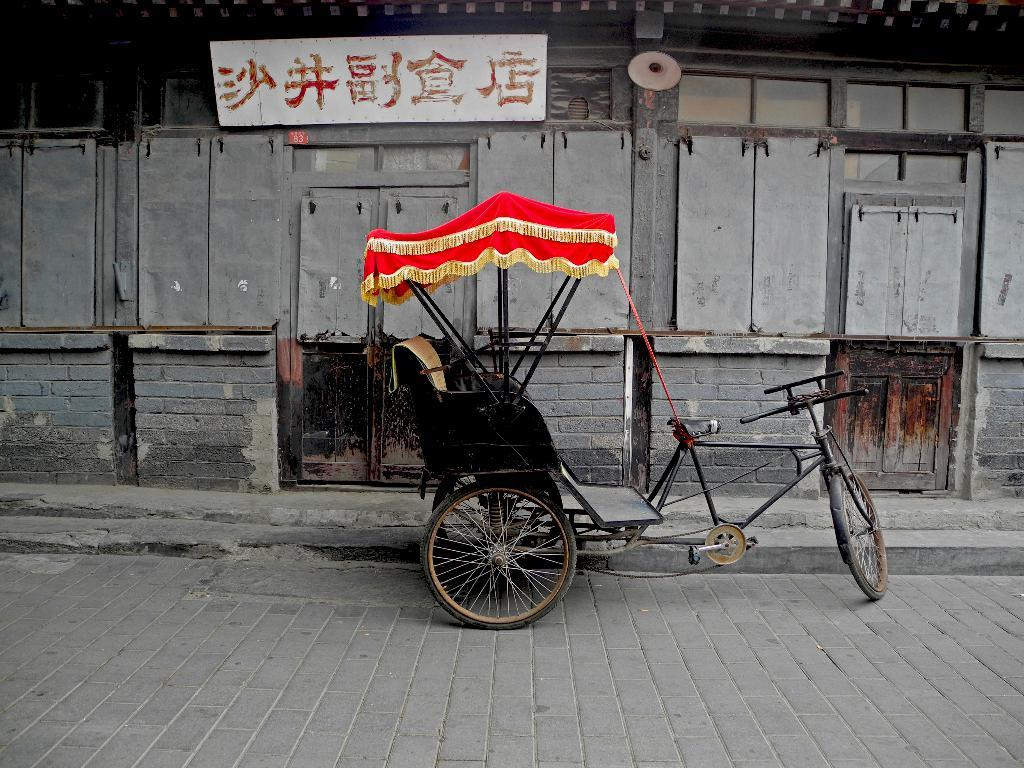What mode of transportation is visible in the image? There is a rickshaw in the image. Where is the rickshaw located? The rickshaw is parked on a road. What can be seen in the background of the image? There is a hoarding in the background of the image. How is the hoarding attached to the building? The hoarding is attached to a building's wall. What type of trouble is the rickshaw driver experiencing in the image? There is no indication of trouble or any issues with the rickshaw driver in the image. 